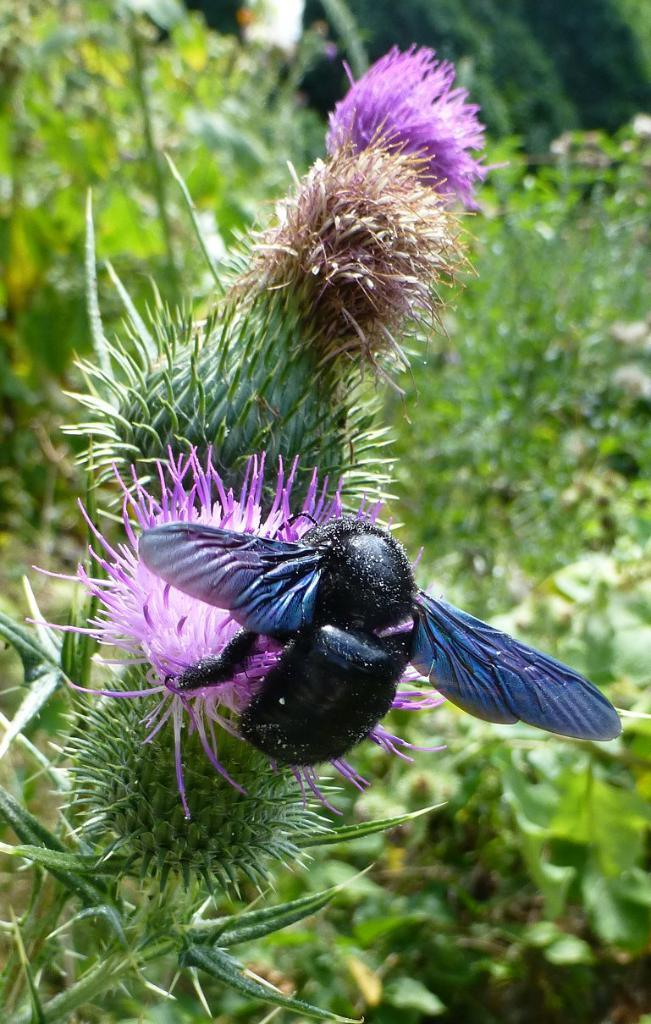What is the main subject in the foreground of the picture? There is an insect in the foreground of the picture. What is the insect sitting on? The insect is on a spear thistle plant. What can be seen in the background of the picture? There are plants visible in the background of the picture. What direction is the pen pointing in the image? There is no pen present in the image. What type of tank can be seen in the background of the image? There is no tank present in the image. 